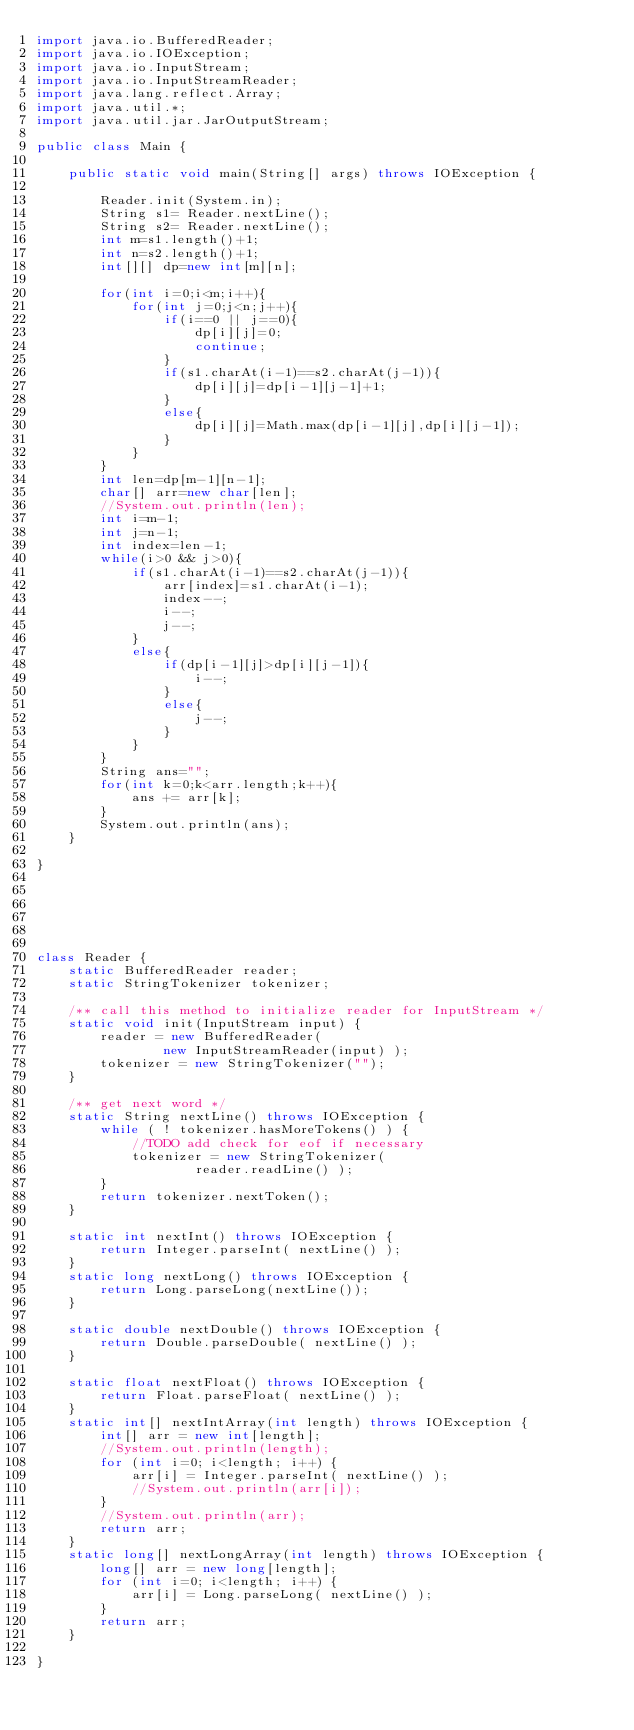<code> <loc_0><loc_0><loc_500><loc_500><_Java_>import java.io.BufferedReader;
import java.io.IOException;
import java.io.InputStream;
import java.io.InputStreamReader;
import java.lang.reflect.Array;
import java.util.*;
import java.util.jar.JarOutputStream;

public class Main {

    public static void main(String[] args) throws IOException {

        Reader.init(System.in);
        String s1= Reader.nextLine();
        String s2= Reader.nextLine();
        int m=s1.length()+1;
        int n=s2.length()+1;
        int[][] dp=new int[m][n];

        for(int i=0;i<m;i++){
            for(int j=0;j<n;j++){
                if(i==0 || j==0){
                    dp[i][j]=0;
                    continue;
                }
                if(s1.charAt(i-1)==s2.charAt(j-1)){
                    dp[i][j]=dp[i-1][j-1]+1;
                }
                else{
                    dp[i][j]=Math.max(dp[i-1][j],dp[i][j-1]);
                }
            }
        }
        int len=dp[m-1][n-1];
        char[] arr=new char[len];
        //System.out.println(len);
        int i=m-1;
        int j=n-1;
        int index=len-1;
        while(i>0 && j>0){
            if(s1.charAt(i-1)==s2.charAt(j-1)){
                arr[index]=s1.charAt(i-1);
                index--;
                i--;
                j--;
            }
            else{
                if(dp[i-1][j]>dp[i][j-1]){
                    i--;
                }
                else{
                    j--;
                }
            }
        }
        String ans="";
        for(int k=0;k<arr.length;k++){
            ans += arr[k];
        }
        System.out.println(ans);
    }

}






class Reader {
    static BufferedReader reader;
    static StringTokenizer tokenizer;

    /** call this method to initialize reader for InputStream */
    static void init(InputStream input) {
        reader = new BufferedReader(
                new InputStreamReader(input) );
        tokenizer = new StringTokenizer("");
    }

    /** get next word */
    static String nextLine() throws IOException {
        while ( ! tokenizer.hasMoreTokens() ) {
            //TODO add check for eof if necessary
            tokenizer = new StringTokenizer(
                    reader.readLine() );
        }
        return tokenizer.nextToken();
    }

    static int nextInt() throws IOException {
        return Integer.parseInt( nextLine() );
    }
    static long nextLong() throws IOException {
        return Long.parseLong(nextLine());
    }

    static double nextDouble() throws IOException {
        return Double.parseDouble( nextLine() );
    }

    static float nextFloat() throws IOException {
        return Float.parseFloat( nextLine() );
    }
    static int[] nextIntArray(int length) throws IOException {
        int[] arr = new int[length];
        //System.out.println(length);
        for (int i=0; i<length; i++) {
            arr[i] = Integer.parseInt( nextLine() );
            //System.out.println(arr[i]);
        }
        //System.out.println(arr);
        return arr;
    }
    static long[] nextLongArray(int length) throws IOException {
        long[] arr = new long[length];
        for (int i=0; i<length; i++) {
            arr[i] = Long.parseLong( nextLine() );
        }
        return arr;
    }

}

</code> 